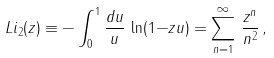Convert formula to latex. <formula><loc_0><loc_0><loc_500><loc_500>L i _ { 2 } ( z ) \equiv - \int _ { 0 } ^ { 1 } { \frac { d u } { u } } \, \ln ( 1 { - } z u ) = \sum _ { n = 1 } ^ { \infty } \, { \frac { z ^ { n } } { n ^ { 2 } } } \, ,</formula> 